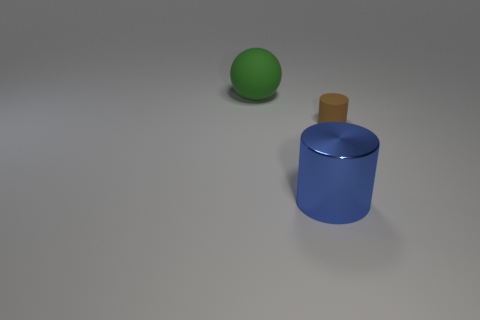Add 2 spheres. How many objects exist? 5 Subtract all balls. How many objects are left? 2 Add 1 brown shiny objects. How many brown shiny objects exist? 1 Subtract 0 gray cylinders. How many objects are left? 3 Subtract all purple cylinders. Subtract all gray blocks. How many cylinders are left? 2 Subtract all large blue objects. Subtract all large matte balls. How many objects are left? 1 Add 1 blue metal cylinders. How many blue metal cylinders are left? 2 